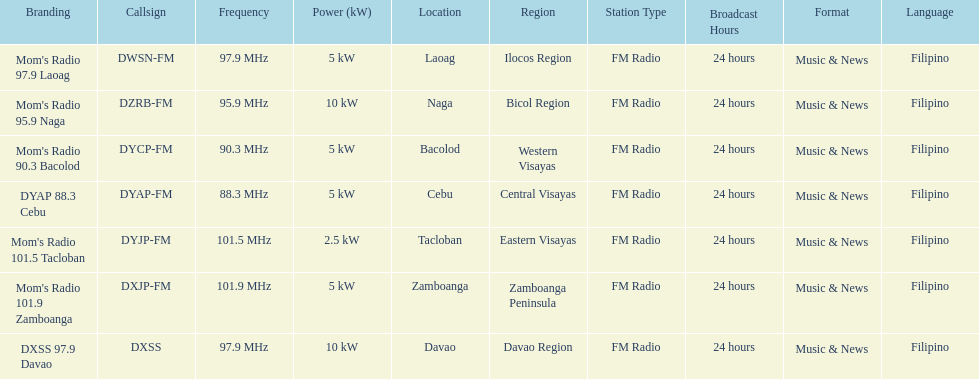What are the frequencies for radios of dyap-fm? 97.9 MHz, 95.9 MHz, 90.3 MHz, 88.3 MHz, 101.5 MHz, 101.9 MHz, 97.9 MHz. What is the lowest frequency? 88.3 MHz. Which radio has this frequency? DYAP 88.3 Cebu. 